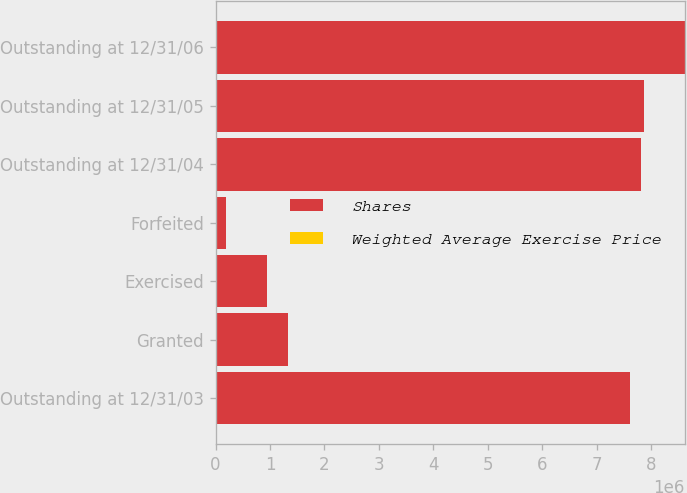Convert chart to OTSL. <chart><loc_0><loc_0><loc_500><loc_500><stacked_bar_chart><ecel><fcel>Outstanding at 12/31/03<fcel>Granted<fcel>Exercised<fcel>Forfeited<fcel>Outstanding at 12/31/04<fcel>Outstanding at 12/31/05<fcel>Outstanding at 12/31/06<nl><fcel>Shares<fcel>7.61718e+06<fcel>1.3324e+06<fcel>943142<fcel>198250<fcel>7.80818e+06<fcel>7.86715e+06<fcel>8.6176e+06<nl><fcel>Weighted Average Exercise Price<fcel>40.06<fcel>43.77<fcel>34.01<fcel>45.09<fcel>41.3<fcel>41.91<fcel>42.77<nl></chart> 